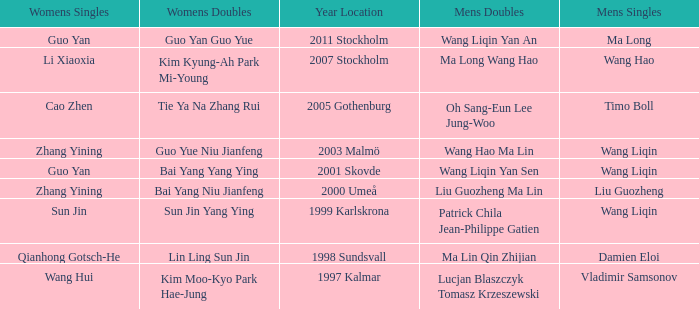How many times has Ma Long won the men's singles? 1.0. 